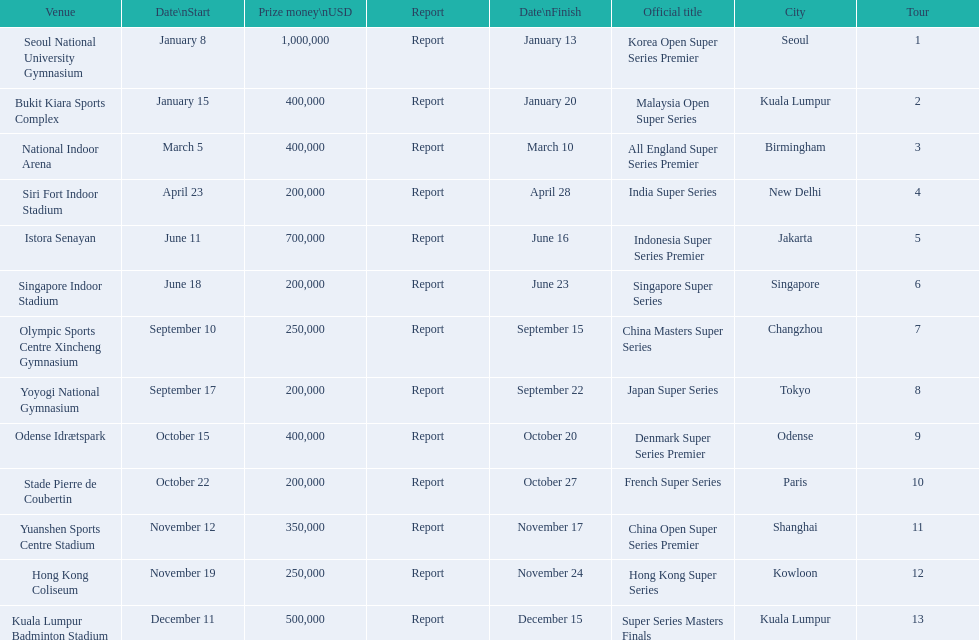What were the titles of the 2013 bwf super series? Korea Open Super Series Premier, Malaysia Open Super Series, All England Super Series Premier, India Super Series, Indonesia Super Series Premier, Singapore Super Series, China Masters Super Series, Japan Super Series, Denmark Super Series Premier, French Super Series, China Open Super Series Premier, Hong Kong Super Series, Super Series Masters Finals. Which were in december? Super Series Masters Finals. 